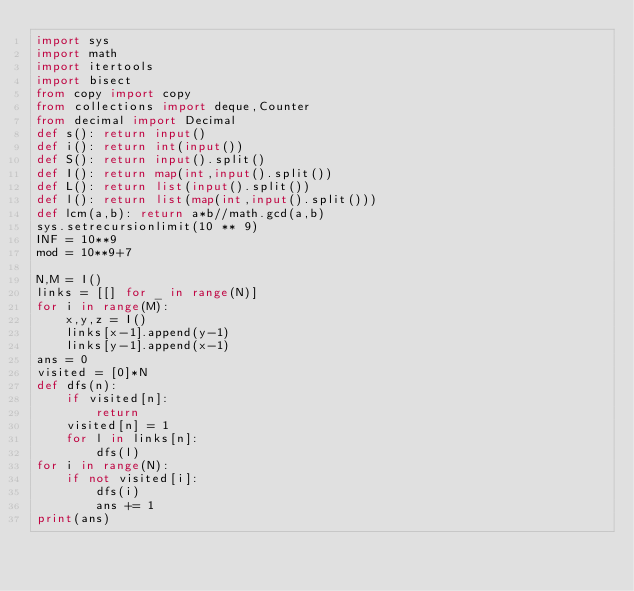<code> <loc_0><loc_0><loc_500><loc_500><_Python_>import sys
import math
import itertools
import bisect
from copy import copy
from collections import deque,Counter
from decimal import Decimal
def s(): return input()
def i(): return int(input())
def S(): return input().split()
def I(): return map(int,input().split())
def L(): return list(input().split())
def l(): return list(map(int,input().split()))
def lcm(a,b): return a*b//math.gcd(a,b)
sys.setrecursionlimit(10 ** 9)
INF = 10**9
mod = 10**9+7

N,M = I()
links = [[] for _ in range(N)]
for i in range(M):
    x,y,z = I()
    links[x-1].append(y-1)
    links[y-1].append(x-1)
ans = 0
visited = [0]*N
def dfs(n):
    if visited[n]:
        return
    visited[n] = 1
    for l in links[n]:
        dfs(l)
for i in range(N):
    if not visited[i]:
        dfs(i)
        ans += 1
print(ans)</code> 